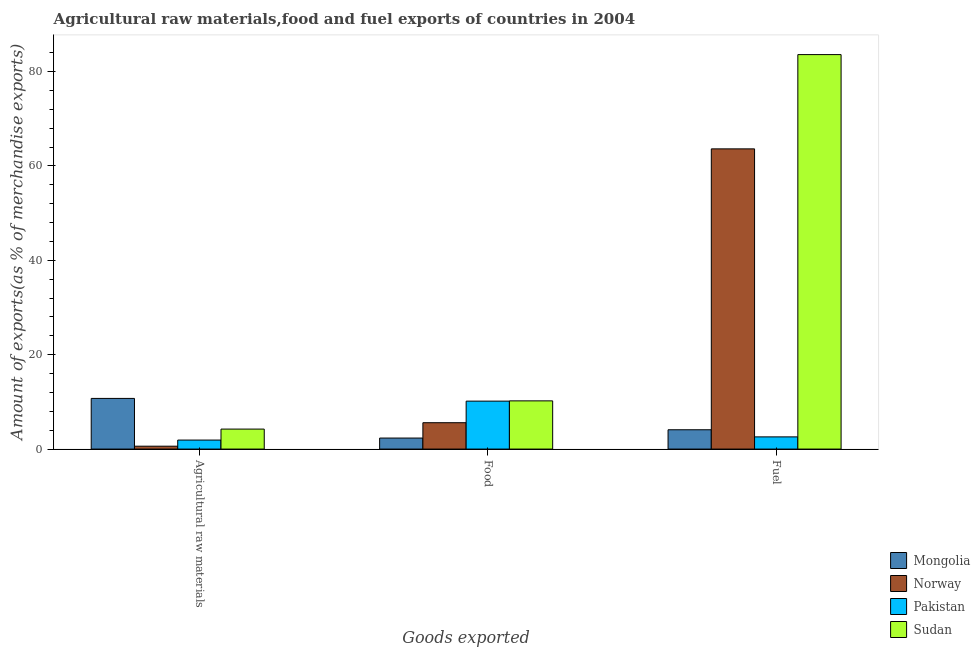How many different coloured bars are there?
Ensure brevity in your answer.  4. Are the number of bars per tick equal to the number of legend labels?
Provide a short and direct response. Yes. How many bars are there on the 2nd tick from the right?
Ensure brevity in your answer.  4. What is the label of the 2nd group of bars from the left?
Ensure brevity in your answer.  Food. What is the percentage of raw materials exports in Norway?
Your answer should be very brief. 0.61. Across all countries, what is the maximum percentage of raw materials exports?
Your answer should be very brief. 10.73. Across all countries, what is the minimum percentage of fuel exports?
Your answer should be very brief. 2.59. In which country was the percentage of fuel exports maximum?
Your answer should be very brief. Sudan. In which country was the percentage of raw materials exports minimum?
Offer a very short reply. Norway. What is the total percentage of fuel exports in the graph?
Ensure brevity in your answer.  153.88. What is the difference between the percentage of raw materials exports in Pakistan and that in Sudan?
Your answer should be compact. -2.33. What is the difference between the percentage of raw materials exports in Norway and the percentage of fuel exports in Mongolia?
Offer a very short reply. -3.48. What is the average percentage of fuel exports per country?
Offer a very short reply. 38.47. What is the difference between the percentage of food exports and percentage of raw materials exports in Pakistan?
Provide a succinct answer. 8.25. What is the ratio of the percentage of raw materials exports in Pakistan to that in Norway?
Offer a terse response. 3.12. Is the percentage of food exports in Norway less than that in Sudan?
Ensure brevity in your answer.  Yes. What is the difference between the highest and the second highest percentage of fuel exports?
Provide a short and direct response. 19.97. What is the difference between the highest and the lowest percentage of raw materials exports?
Your answer should be compact. 10.12. In how many countries, is the percentage of raw materials exports greater than the average percentage of raw materials exports taken over all countries?
Keep it short and to the point. 1. Is the sum of the percentage of raw materials exports in Pakistan and Norway greater than the maximum percentage of food exports across all countries?
Give a very brief answer. No. What does the 4th bar from the left in Food represents?
Keep it short and to the point. Sudan. What does the 4th bar from the right in Fuel represents?
Your answer should be compact. Mongolia. How many bars are there?
Provide a short and direct response. 12. Are all the bars in the graph horizontal?
Your answer should be very brief. No. Does the graph contain grids?
Give a very brief answer. No. Where does the legend appear in the graph?
Your answer should be very brief. Bottom right. How are the legend labels stacked?
Ensure brevity in your answer.  Vertical. What is the title of the graph?
Provide a short and direct response. Agricultural raw materials,food and fuel exports of countries in 2004. Does "Central Europe" appear as one of the legend labels in the graph?
Offer a very short reply. No. What is the label or title of the X-axis?
Make the answer very short. Goods exported. What is the label or title of the Y-axis?
Ensure brevity in your answer.  Amount of exports(as % of merchandise exports). What is the Amount of exports(as % of merchandise exports) in Mongolia in Agricultural raw materials?
Your answer should be very brief. 10.73. What is the Amount of exports(as % of merchandise exports) in Norway in Agricultural raw materials?
Make the answer very short. 0.61. What is the Amount of exports(as % of merchandise exports) in Pakistan in Agricultural raw materials?
Your response must be concise. 1.91. What is the Amount of exports(as % of merchandise exports) in Sudan in Agricultural raw materials?
Your answer should be compact. 4.23. What is the Amount of exports(as % of merchandise exports) of Mongolia in Food?
Your answer should be compact. 2.33. What is the Amount of exports(as % of merchandise exports) of Norway in Food?
Offer a terse response. 5.59. What is the Amount of exports(as % of merchandise exports) in Pakistan in Food?
Provide a short and direct response. 10.16. What is the Amount of exports(as % of merchandise exports) of Sudan in Food?
Keep it short and to the point. 10.22. What is the Amount of exports(as % of merchandise exports) of Mongolia in Fuel?
Give a very brief answer. 4.09. What is the Amount of exports(as % of merchandise exports) in Norway in Fuel?
Keep it short and to the point. 63.61. What is the Amount of exports(as % of merchandise exports) of Pakistan in Fuel?
Your response must be concise. 2.59. What is the Amount of exports(as % of merchandise exports) of Sudan in Fuel?
Offer a terse response. 83.59. Across all Goods exported, what is the maximum Amount of exports(as % of merchandise exports) in Mongolia?
Offer a very short reply. 10.73. Across all Goods exported, what is the maximum Amount of exports(as % of merchandise exports) of Norway?
Provide a short and direct response. 63.61. Across all Goods exported, what is the maximum Amount of exports(as % of merchandise exports) in Pakistan?
Offer a very short reply. 10.16. Across all Goods exported, what is the maximum Amount of exports(as % of merchandise exports) in Sudan?
Your answer should be compact. 83.59. Across all Goods exported, what is the minimum Amount of exports(as % of merchandise exports) of Mongolia?
Offer a terse response. 2.33. Across all Goods exported, what is the minimum Amount of exports(as % of merchandise exports) of Norway?
Give a very brief answer. 0.61. Across all Goods exported, what is the minimum Amount of exports(as % of merchandise exports) in Pakistan?
Offer a very short reply. 1.91. Across all Goods exported, what is the minimum Amount of exports(as % of merchandise exports) in Sudan?
Offer a terse response. 4.23. What is the total Amount of exports(as % of merchandise exports) of Mongolia in the graph?
Provide a succinct answer. 17.16. What is the total Amount of exports(as % of merchandise exports) in Norway in the graph?
Keep it short and to the point. 69.81. What is the total Amount of exports(as % of merchandise exports) in Pakistan in the graph?
Make the answer very short. 14.65. What is the total Amount of exports(as % of merchandise exports) in Sudan in the graph?
Ensure brevity in your answer.  98.04. What is the difference between the Amount of exports(as % of merchandise exports) of Mongolia in Agricultural raw materials and that in Food?
Ensure brevity in your answer.  8.4. What is the difference between the Amount of exports(as % of merchandise exports) of Norway in Agricultural raw materials and that in Food?
Offer a terse response. -4.98. What is the difference between the Amount of exports(as % of merchandise exports) in Pakistan in Agricultural raw materials and that in Food?
Offer a very short reply. -8.25. What is the difference between the Amount of exports(as % of merchandise exports) of Sudan in Agricultural raw materials and that in Food?
Keep it short and to the point. -5.98. What is the difference between the Amount of exports(as % of merchandise exports) in Mongolia in Agricultural raw materials and that in Fuel?
Keep it short and to the point. 6.64. What is the difference between the Amount of exports(as % of merchandise exports) in Norway in Agricultural raw materials and that in Fuel?
Your answer should be very brief. -63. What is the difference between the Amount of exports(as % of merchandise exports) in Pakistan in Agricultural raw materials and that in Fuel?
Your response must be concise. -0.68. What is the difference between the Amount of exports(as % of merchandise exports) in Sudan in Agricultural raw materials and that in Fuel?
Provide a succinct answer. -79.35. What is the difference between the Amount of exports(as % of merchandise exports) of Mongolia in Food and that in Fuel?
Offer a very short reply. -1.76. What is the difference between the Amount of exports(as % of merchandise exports) in Norway in Food and that in Fuel?
Ensure brevity in your answer.  -58.03. What is the difference between the Amount of exports(as % of merchandise exports) of Pakistan in Food and that in Fuel?
Give a very brief answer. 7.57. What is the difference between the Amount of exports(as % of merchandise exports) in Sudan in Food and that in Fuel?
Offer a terse response. -73.37. What is the difference between the Amount of exports(as % of merchandise exports) in Mongolia in Agricultural raw materials and the Amount of exports(as % of merchandise exports) in Norway in Food?
Keep it short and to the point. 5.15. What is the difference between the Amount of exports(as % of merchandise exports) of Mongolia in Agricultural raw materials and the Amount of exports(as % of merchandise exports) of Pakistan in Food?
Your answer should be compact. 0.57. What is the difference between the Amount of exports(as % of merchandise exports) in Mongolia in Agricultural raw materials and the Amount of exports(as % of merchandise exports) in Sudan in Food?
Offer a very short reply. 0.52. What is the difference between the Amount of exports(as % of merchandise exports) in Norway in Agricultural raw materials and the Amount of exports(as % of merchandise exports) in Pakistan in Food?
Ensure brevity in your answer.  -9.55. What is the difference between the Amount of exports(as % of merchandise exports) of Norway in Agricultural raw materials and the Amount of exports(as % of merchandise exports) of Sudan in Food?
Your response must be concise. -9.6. What is the difference between the Amount of exports(as % of merchandise exports) in Pakistan in Agricultural raw materials and the Amount of exports(as % of merchandise exports) in Sudan in Food?
Offer a terse response. -8.31. What is the difference between the Amount of exports(as % of merchandise exports) of Mongolia in Agricultural raw materials and the Amount of exports(as % of merchandise exports) of Norway in Fuel?
Your answer should be compact. -52.88. What is the difference between the Amount of exports(as % of merchandise exports) in Mongolia in Agricultural raw materials and the Amount of exports(as % of merchandise exports) in Pakistan in Fuel?
Provide a short and direct response. 8.15. What is the difference between the Amount of exports(as % of merchandise exports) of Mongolia in Agricultural raw materials and the Amount of exports(as % of merchandise exports) of Sudan in Fuel?
Offer a terse response. -72.85. What is the difference between the Amount of exports(as % of merchandise exports) of Norway in Agricultural raw materials and the Amount of exports(as % of merchandise exports) of Pakistan in Fuel?
Your answer should be compact. -1.97. What is the difference between the Amount of exports(as % of merchandise exports) in Norway in Agricultural raw materials and the Amount of exports(as % of merchandise exports) in Sudan in Fuel?
Give a very brief answer. -82.97. What is the difference between the Amount of exports(as % of merchandise exports) in Pakistan in Agricultural raw materials and the Amount of exports(as % of merchandise exports) in Sudan in Fuel?
Offer a very short reply. -81.68. What is the difference between the Amount of exports(as % of merchandise exports) in Mongolia in Food and the Amount of exports(as % of merchandise exports) in Norway in Fuel?
Ensure brevity in your answer.  -61.28. What is the difference between the Amount of exports(as % of merchandise exports) in Mongolia in Food and the Amount of exports(as % of merchandise exports) in Pakistan in Fuel?
Ensure brevity in your answer.  -0.25. What is the difference between the Amount of exports(as % of merchandise exports) in Mongolia in Food and the Amount of exports(as % of merchandise exports) in Sudan in Fuel?
Your answer should be very brief. -81.25. What is the difference between the Amount of exports(as % of merchandise exports) of Norway in Food and the Amount of exports(as % of merchandise exports) of Pakistan in Fuel?
Your answer should be very brief. 3. What is the difference between the Amount of exports(as % of merchandise exports) in Norway in Food and the Amount of exports(as % of merchandise exports) in Sudan in Fuel?
Provide a short and direct response. -78. What is the difference between the Amount of exports(as % of merchandise exports) of Pakistan in Food and the Amount of exports(as % of merchandise exports) of Sudan in Fuel?
Offer a very short reply. -73.43. What is the average Amount of exports(as % of merchandise exports) of Mongolia per Goods exported?
Provide a succinct answer. 5.72. What is the average Amount of exports(as % of merchandise exports) of Norway per Goods exported?
Offer a terse response. 23.27. What is the average Amount of exports(as % of merchandise exports) in Pakistan per Goods exported?
Make the answer very short. 4.88. What is the average Amount of exports(as % of merchandise exports) in Sudan per Goods exported?
Offer a very short reply. 32.68. What is the difference between the Amount of exports(as % of merchandise exports) of Mongolia and Amount of exports(as % of merchandise exports) of Norway in Agricultural raw materials?
Provide a succinct answer. 10.12. What is the difference between the Amount of exports(as % of merchandise exports) in Mongolia and Amount of exports(as % of merchandise exports) in Pakistan in Agricultural raw materials?
Ensure brevity in your answer.  8.83. What is the difference between the Amount of exports(as % of merchandise exports) in Mongolia and Amount of exports(as % of merchandise exports) in Sudan in Agricultural raw materials?
Ensure brevity in your answer.  6.5. What is the difference between the Amount of exports(as % of merchandise exports) in Norway and Amount of exports(as % of merchandise exports) in Pakistan in Agricultural raw materials?
Make the answer very short. -1.3. What is the difference between the Amount of exports(as % of merchandise exports) in Norway and Amount of exports(as % of merchandise exports) in Sudan in Agricultural raw materials?
Provide a succinct answer. -3.62. What is the difference between the Amount of exports(as % of merchandise exports) of Pakistan and Amount of exports(as % of merchandise exports) of Sudan in Agricultural raw materials?
Make the answer very short. -2.33. What is the difference between the Amount of exports(as % of merchandise exports) in Mongolia and Amount of exports(as % of merchandise exports) in Norway in Food?
Give a very brief answer. -3.25. What is the difference between the Amount of exports(as % of merchandise exports) in Mongolia and Amount of exports(as % of merchandise exports) in Pakistan in Food?
Give a very brief answer. -7.83. What is the difference between the Amount of exports(as % of merchandise exports) in Mongolia and Amount of exports(as % of merchandise exports) in Sudan in Food?
Your response must be concise. -7.88. What is the difference between the Amount of exports(as % of merchandise exports) in Norway and Amount of exports(as % of merchandise exports) in Pakistan in Food?
Give a very brief answer. -4.57. What is the difference between the Amount of exports(as % of merchandise exports) in Norway and Amount of exports(as % of merchandise exports) in Sudan in Food?
Give a very brief answer. -4.63. What is the difference between the Amount of exports(as % of merchandise exports) of Pakistan and Amount of exports(as % of merchandise exports) of Sudan in Food?
Provide a short and direct response. -0.06. What is the difference between the Amount of exports(as % of merchandise exports) in Mongolia and Amount of exports(as % of merchandise exports) in Norway in Fuel?
Your answer should be compact. -59.52. What is the difference between the Amount of exports(as % of merchandise exports) of Mongolia and Amount of exports(as % of merchandise exports) of Pakistan in Fuel?
Provide a succinct answer. 1.51. What is the difference between the Amount of exports(as % of merchandise exports) of Mongolia and Amount of exports(as % of merchandise exports) of Sudan in Fuel?
Give a very brief answer. -79.49. What is the difference between the Amount of exports(as % of merchandise exports) of Norway and Amount of exports(as % of merchandise exports) of Pakistan in Fuel?
Make the answer very short. 61.03. What is the difference between the Amount of exports(as % of merchandise exports) in Norway and Amount of exports(as % of merchandise exports) in Sudan in Fuel?
Ensure brevity in your answer.  -19.97. What is the difference between the Amount of exports(as % of merchandise exports) of Pakistan and Amount of exports(as % of merchandise exports) of Sudan in Fuel?
Make the answer very short. -81. What is the ratio of the Amount of exports(as % of merchandise exports) in Mongolia in Agricultural raw materials to that in Food?
Provide a short and direct response. 4.6. What is the ratio of the Amount of exports(as % of merchandise exports) of Norway in Agricultural raw materials to that in Food?
Offer a very short reply. 0.11. What is the ratio of the Amount of exports(as % of merchandise exports) in Pakistan in Agricultural raw materials to that in Food?
Your answer should be very brief. 0.19. What is the ratio of the Amount of exports(as % of merchandise exports) of Sudan in Agricultural raw materials to that in Food?
Offer a very short reply. 0.41. What is the ratio of the Amount of exports(as % of merchandise exports) in Mongolia in Agricultural raw materials to that in Fuel?
Your answer should be compact. 2.62. What is the ratio of the Amount of exports(as % of merchandise exports) of Norway in Agricultural raw materials to that in Fuel?
Provide a succinct answer. 0.01. What is the ratio of the Amount of exports(as % of merchandise exports) of Pakistan in Agricultural raw materials to that in Fuel?
Your answer should be very brief. 0.74. What is the ratio of the Amount of exports(as % of merchandise exports) of Sudan in Agricultural raw materials to that in Fuel?
Give a very brief answer. 0.05. What is the ratio of the Amount of exports(as % of merchandise exports) of Mongolia in Food to that in Fuel?
Provide a short and direct response. 0.57. What is the ratio of the Amount of exports(as % of merchandise exports) of Norway in Food to that in Fuel?
Keep it short and to the point. 0.09. What is the ratio of the Amount of exports(as % of merchandise exports) in Pakistan in Food to that in Fuel?
Provide a short and direct response. 3.93. What is the ratio of the Amount of exports(as % of merchandise exports) of Sudan in Food to that in Fuel?
Provide a short and direct response. 0.12. What is the difference between the highest and the second highest Amount of exports(as % of merchandise exports) in Mongolia?
Your answer should be compact. 6.64. What is the difference between the highest and the second highest Amount of exports(as % of merchandise exports) of Norway?
Offer a terse response. 58.03. What is the difference between the highest and the second highest Amount of exports(as % of merchandise exports) in Pakistan?
Your response must be concise. 7.57. What is the difference between the highest and the second highest Amount of exports(as % of merchandise exports) in Sudan?
Provide a succinct answer. 73.37. What is the difference between the highest and the lowest Amount of exports(as % of merchandise exports) of Mongolia?
Give a very brief answer. 8.4. What is the difference between the highest and the lowest Amount of exports(as % of merchandise exports) of Norway?
Make the answer very short. 63. What is the difference between the highest and the lowest Amount of exports(as % of merchandise exports) of Pakistan?
Keep it short and to the point. 8.25. What is the difference between the highest and the lowest Amount of exports(as % of merchandise exports) in Sudan?
Ensure brevity in your answer.  79.35. 